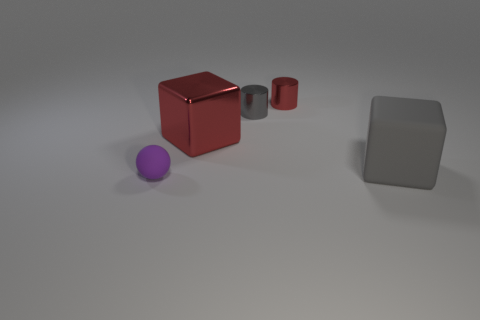The thing that is the same color as the big metal block is what shape?
Offer a very short reply. Cylinder. What size is the metallic object left of the small gray cylinder?
Provide a succinct answer. Large. What shape is the tiny object that is made of the same material as the big gray cube?
Offer a very short reply. Sphere. Is the gray cube made of the same material as the object that is to the left of the metal cube?
Your answer should be very brief. Yes. There is a metal thing on the left side of the tiny gray thing; is it the same shape as the gray rubber object?
Keep it short and to the point. Yes. There is another large thing that is the same shape as the big red metallic thing; what is it made of?
Make the answer very short. Rubber. Does the large metallic object have the same shape as the matte object right of the small purple matte sphere?
Ensure brevity in your answer.  Yes. There is a small object that is both behind the small purple thing and in front of the small red cylinder; what is its color?
Offer a very short reply. Gray. Is there a yellow shiny cube?
Keep it short and to the point. No. Is the number of purple rubber balls behind the gray cylinder the same as the number of big red metal balls?
Give a very brief answer. Yes. 